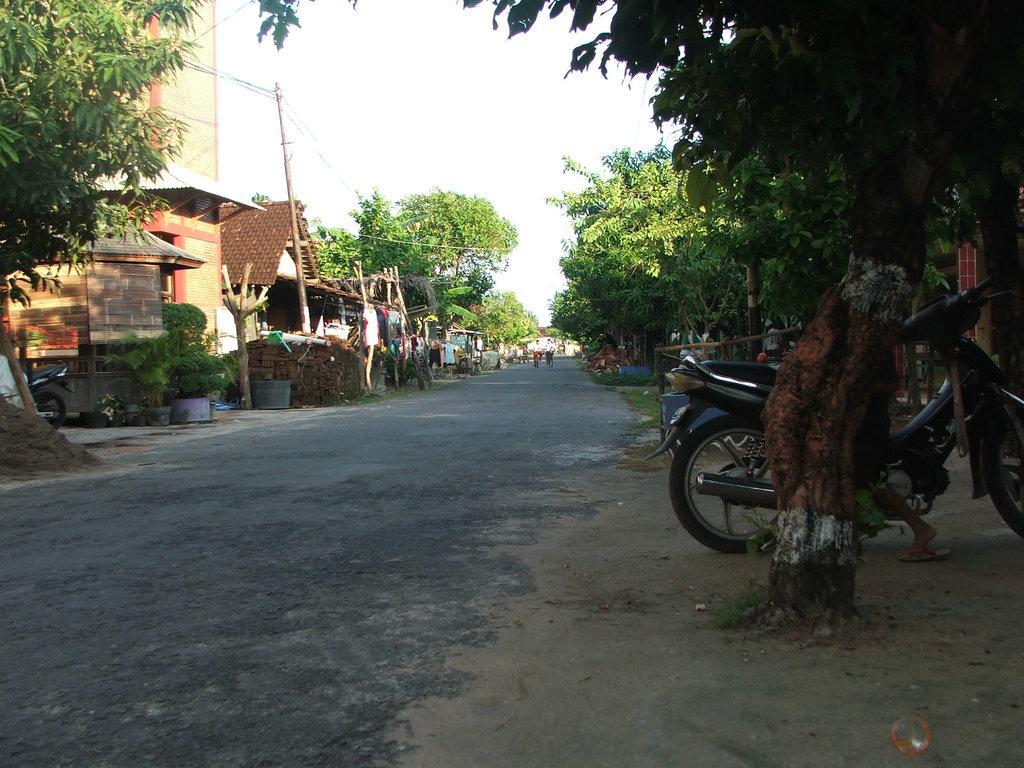Could you give a brief overview of what you see in this image? In this image, I can see the houses, a building, trees, plants and a current pole with wires. There are two persons on the road. On the right side of the image, I can see a person and a motorbike, which is parked behind a tree. In the background, there is the sky. 